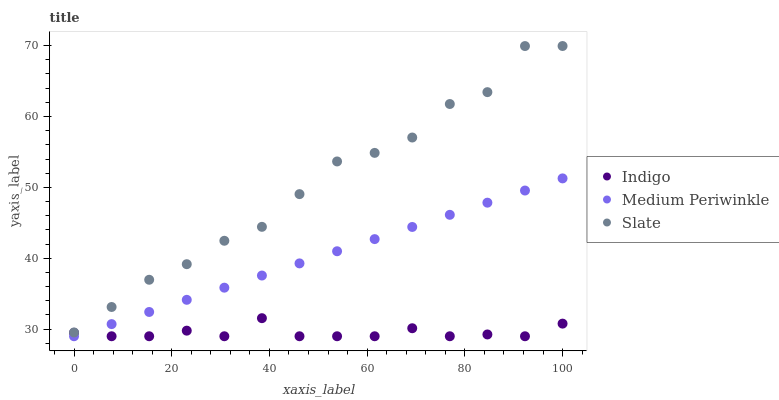Does Indigo have the minimum area under the curve?
Answer yes or no. Yes. Does Slate have the maximum area under the curve?
Answer yes or no. Yes. Does Slate have the minimum area under the curve?
Answer yes or no. No. Does Indigo have the maximum area under the curve?
Answer yes or no. No. Is Medium Periwinkle the smoothest?
Answer yes or no. Yes. Is Slate the roughest?
Answer yes or no. Yes. Is Indigo the smoothest?
Answer yes or no. No. Is Indigo the roughest?
Answer yes or no. No. Does Medium Periwinkle have the lowest value?
Answer yes or no. Yes. Does Slate have the lowest value?
Answer yes or no. No. Does Slate have the highest value?
Answer yes or no. Yes. Does Indigo have the highest value?
Answer yes or no. No. Is Medium Periwinkle less than Slate?
Answer yes or no. Yes. Is Slate greater than Medium Periwinkle?
Answer yes or no. Yes. Does Indigo intersect Medium Periwinkle?
Answer yes or no. Yes. Is Indigo less than Medium Periwinkle?
Answer yes or no. No. Is Indigo greater than Medium Periwinkle?
Answer yes or no. No. Does Medium Periwinkle intersect Slate?
Answer yes or no. No. 